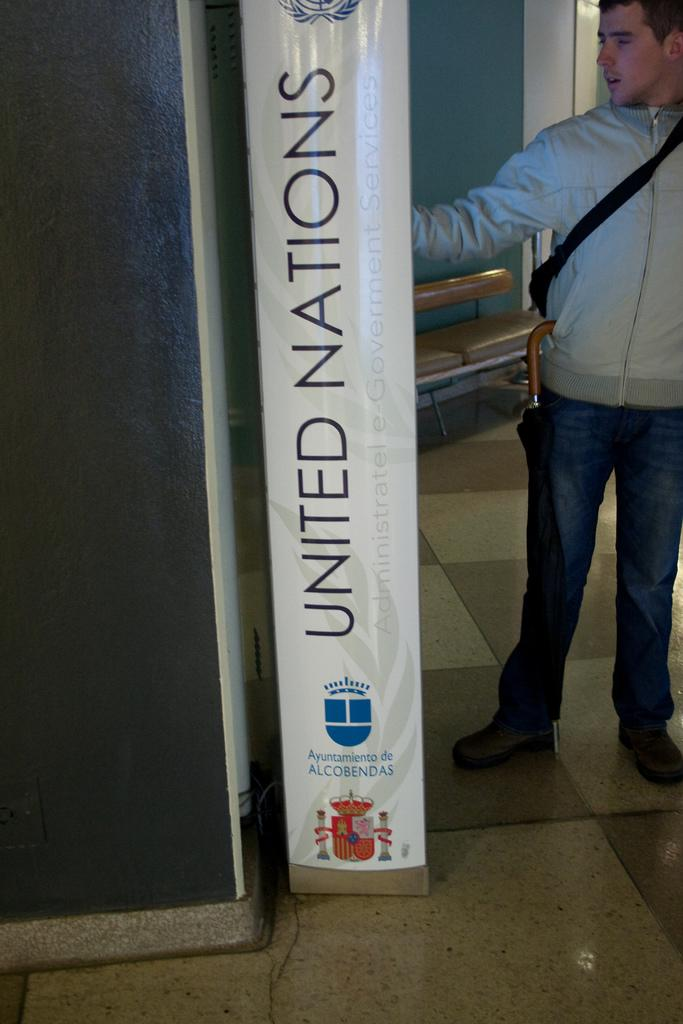<image>
Share a concise interpretation of the image provided. A person standing next to a large United Nations sign. 